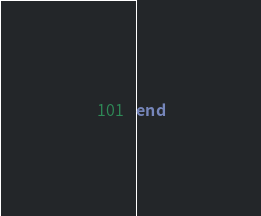<code> <loc_0><loc_0><loc_500><loc_500><_Ruby_>end
</code> 